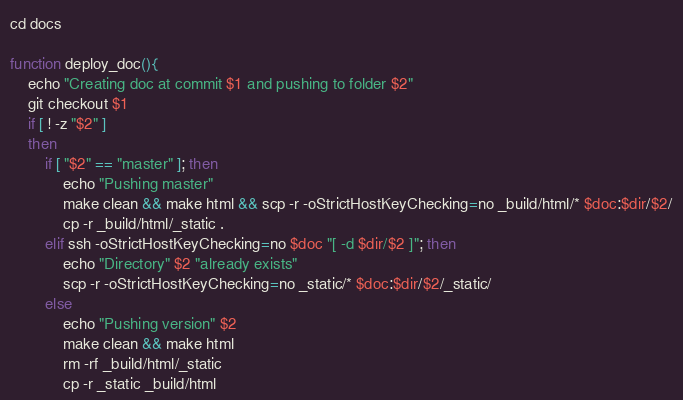Convert code to text. <code><loc_0><loc_0><loc_500><loc_500><_Bash_>cd docs

function deploy_doc(){
	echo "Creating doc at commit $1 and pushing to folder $2"
	git checkout $1
	if [ ! -z "$2" ]
	then
		if [ "$2" == "master" ]; then
		    echo "Pushing master"
			make clean && make html && scp -r -oStrictHostKeyChecking=no _build/html/* $doc:$dir/$2/
			cp -r _build/html/_static .
		elif ssh -oStrictHostKeyChecking=no $doc "[ -d $dir/$2 ]"; then
			echo "Directory" $2 "already exists"
			scp -r -oStrictHostKeyChecking=no _static/* $doc:$dir/$2/_static/
		else
			echo "Pushing version" $2
			make clean && make html
			rm -rf _build/html/_static
			cp -r _static _build/html</code> 